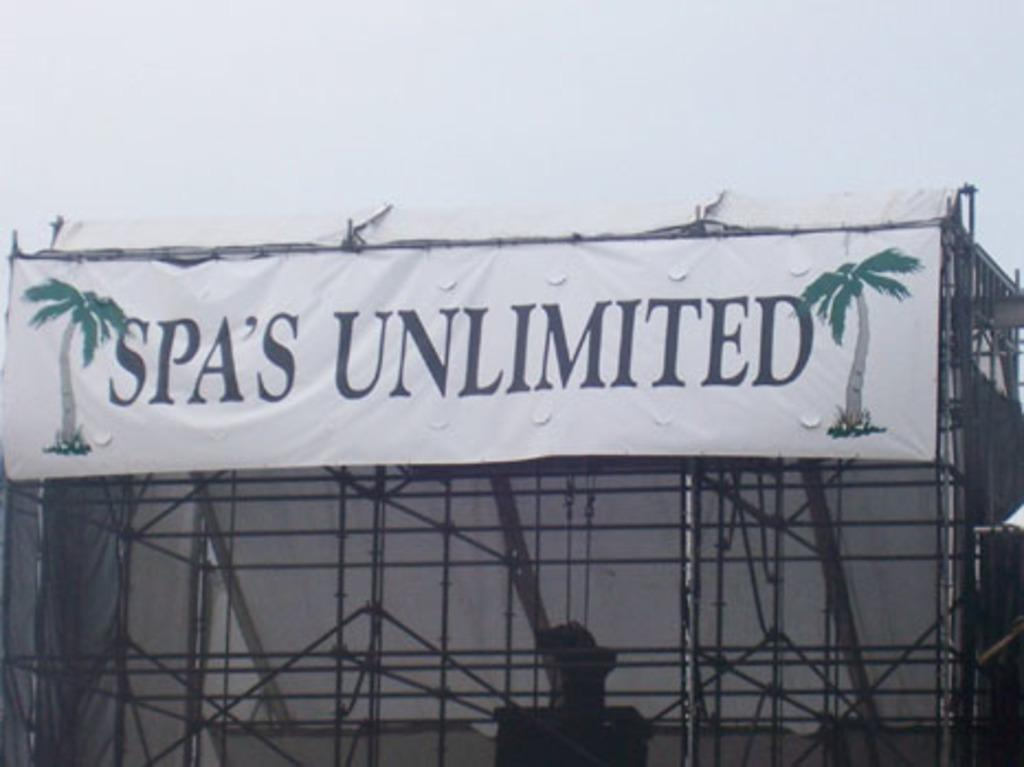<image>
Write a terse but informative summary of the picture. Spa's Unlimited is the advertiser for the stage show. 